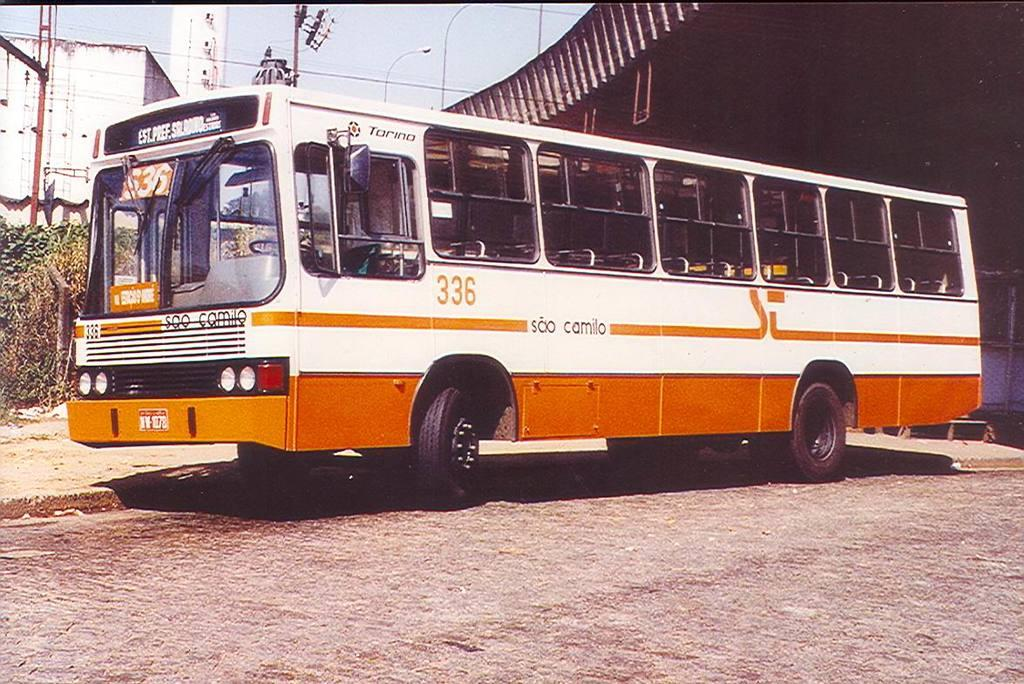What is the main subject of the image? The main subject of the image is a bus. What colors are used for the bus in the image? The bus is in a white and orange color combination. What feature does the bus have that allows passengers to see outside? The bus has windows. Where is the bus located in the image? The bus is on the road. What type of sand can be seen being used for writing in the image? There is no sand or writing present in the image. Reasoning: Let's think step by step in order to create the absurd question. We start by selecting one of the provided absurd topics, which is "sand." Then, we craft a question that involves the absurd topic but is not present in the image. In this case, we ask about sand being used for writing, which is not present in the image. 